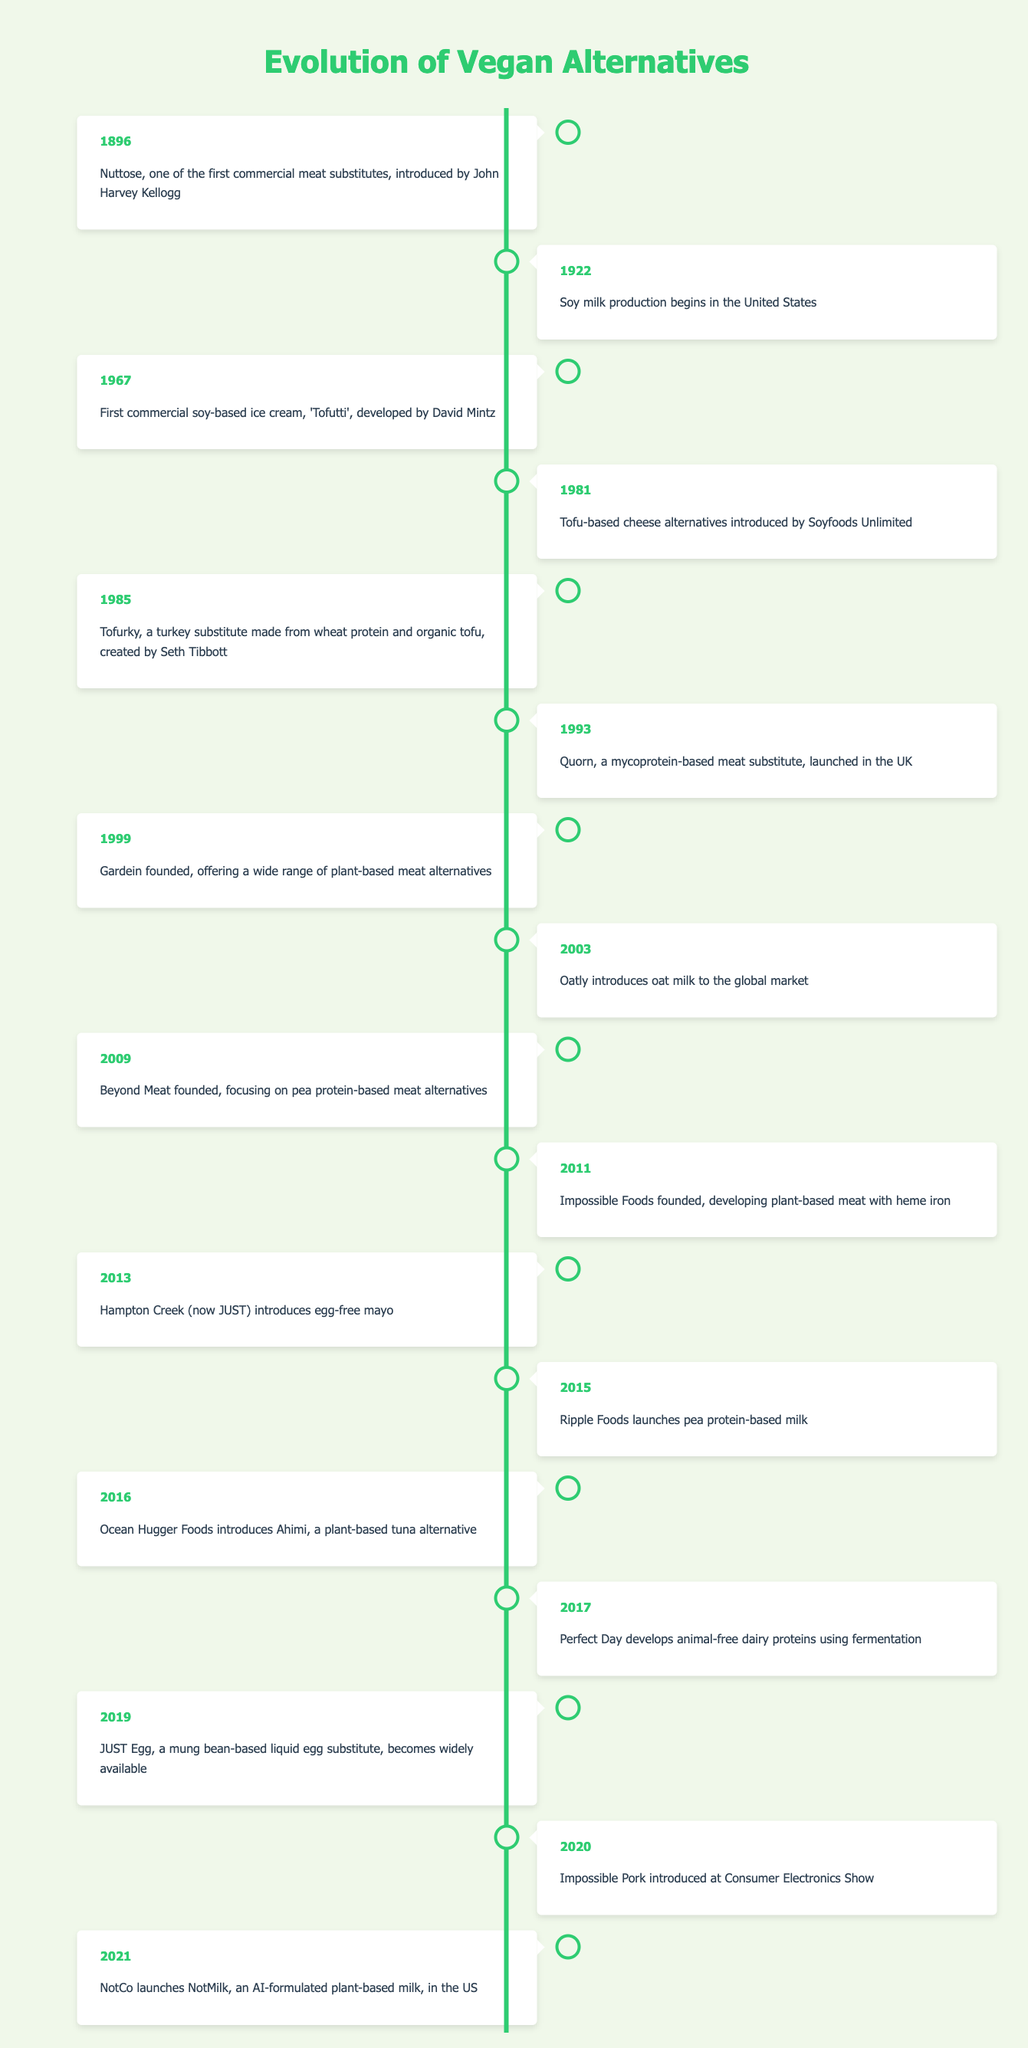What year was Nuttose introduced as a meat substitute? According to the timeline, Nuttose was introduced in the year 1896.
Answer: 1896 Which company developed the first commercial soy-based ice cream? The timeline indicates that Tofutti, the first commercial soy-based ice cream, was developed by David Mintz in 1967.
Answer: Tofutti How many years passed between the introduction of Tofurky and Quorn? Tofurky was created in 1985, and Quorn was launched in 1993. We calculate the difference: 1993 - 1985 = 8 years.
Answer: 8 years Was the introduction of egg-free mayo by Hampton Creek before or after the launch of Gardein? Gardein was founded in 1999 and Hampton Creek introduced egg-free mayo in 2013. Since 2013 is after 1999, the statement is true.
Answer: Yes Identify the last event listed in the timeline. The last event presented in the timeline is NotCo launching NotMilk in 2021.
Answer: NotCo launches NotMilk in 2021 Which two products were introduced most closely together, and what were their years? The timeline shows that JUST Egg was introduced in 2019 and Impossible Pork was introduced in 2020. Therefore, these two products were introduced within a year (1 year apart).
Answer: JUST Egg in 2019 and Impossible Pork in 2020 What type of protein does Beyond Meat focus on for its products? According to the timeline, Beyond Meat focuses on pea protein-based meat alternatives.
Answer: Pea protein How many events involved dairy alternatives? The timeline lists Oatly introducing oat milk in 2003, Perfect Day developing animal-free dairy proteins in 2017, and the launch of JUST Egg in 2019. Thus, there are three events related to dairy alternatives.
Answer: 3 events What was the trend in the introduction of vegan products from 2000 to 2021? Analyzing the timeline from 2000 to 2021, there is a notable increase in the variety of vegan products introduced, reflecting a growing market interest and innovation in plant-based food alternatives.
Answer: Increase in variety 